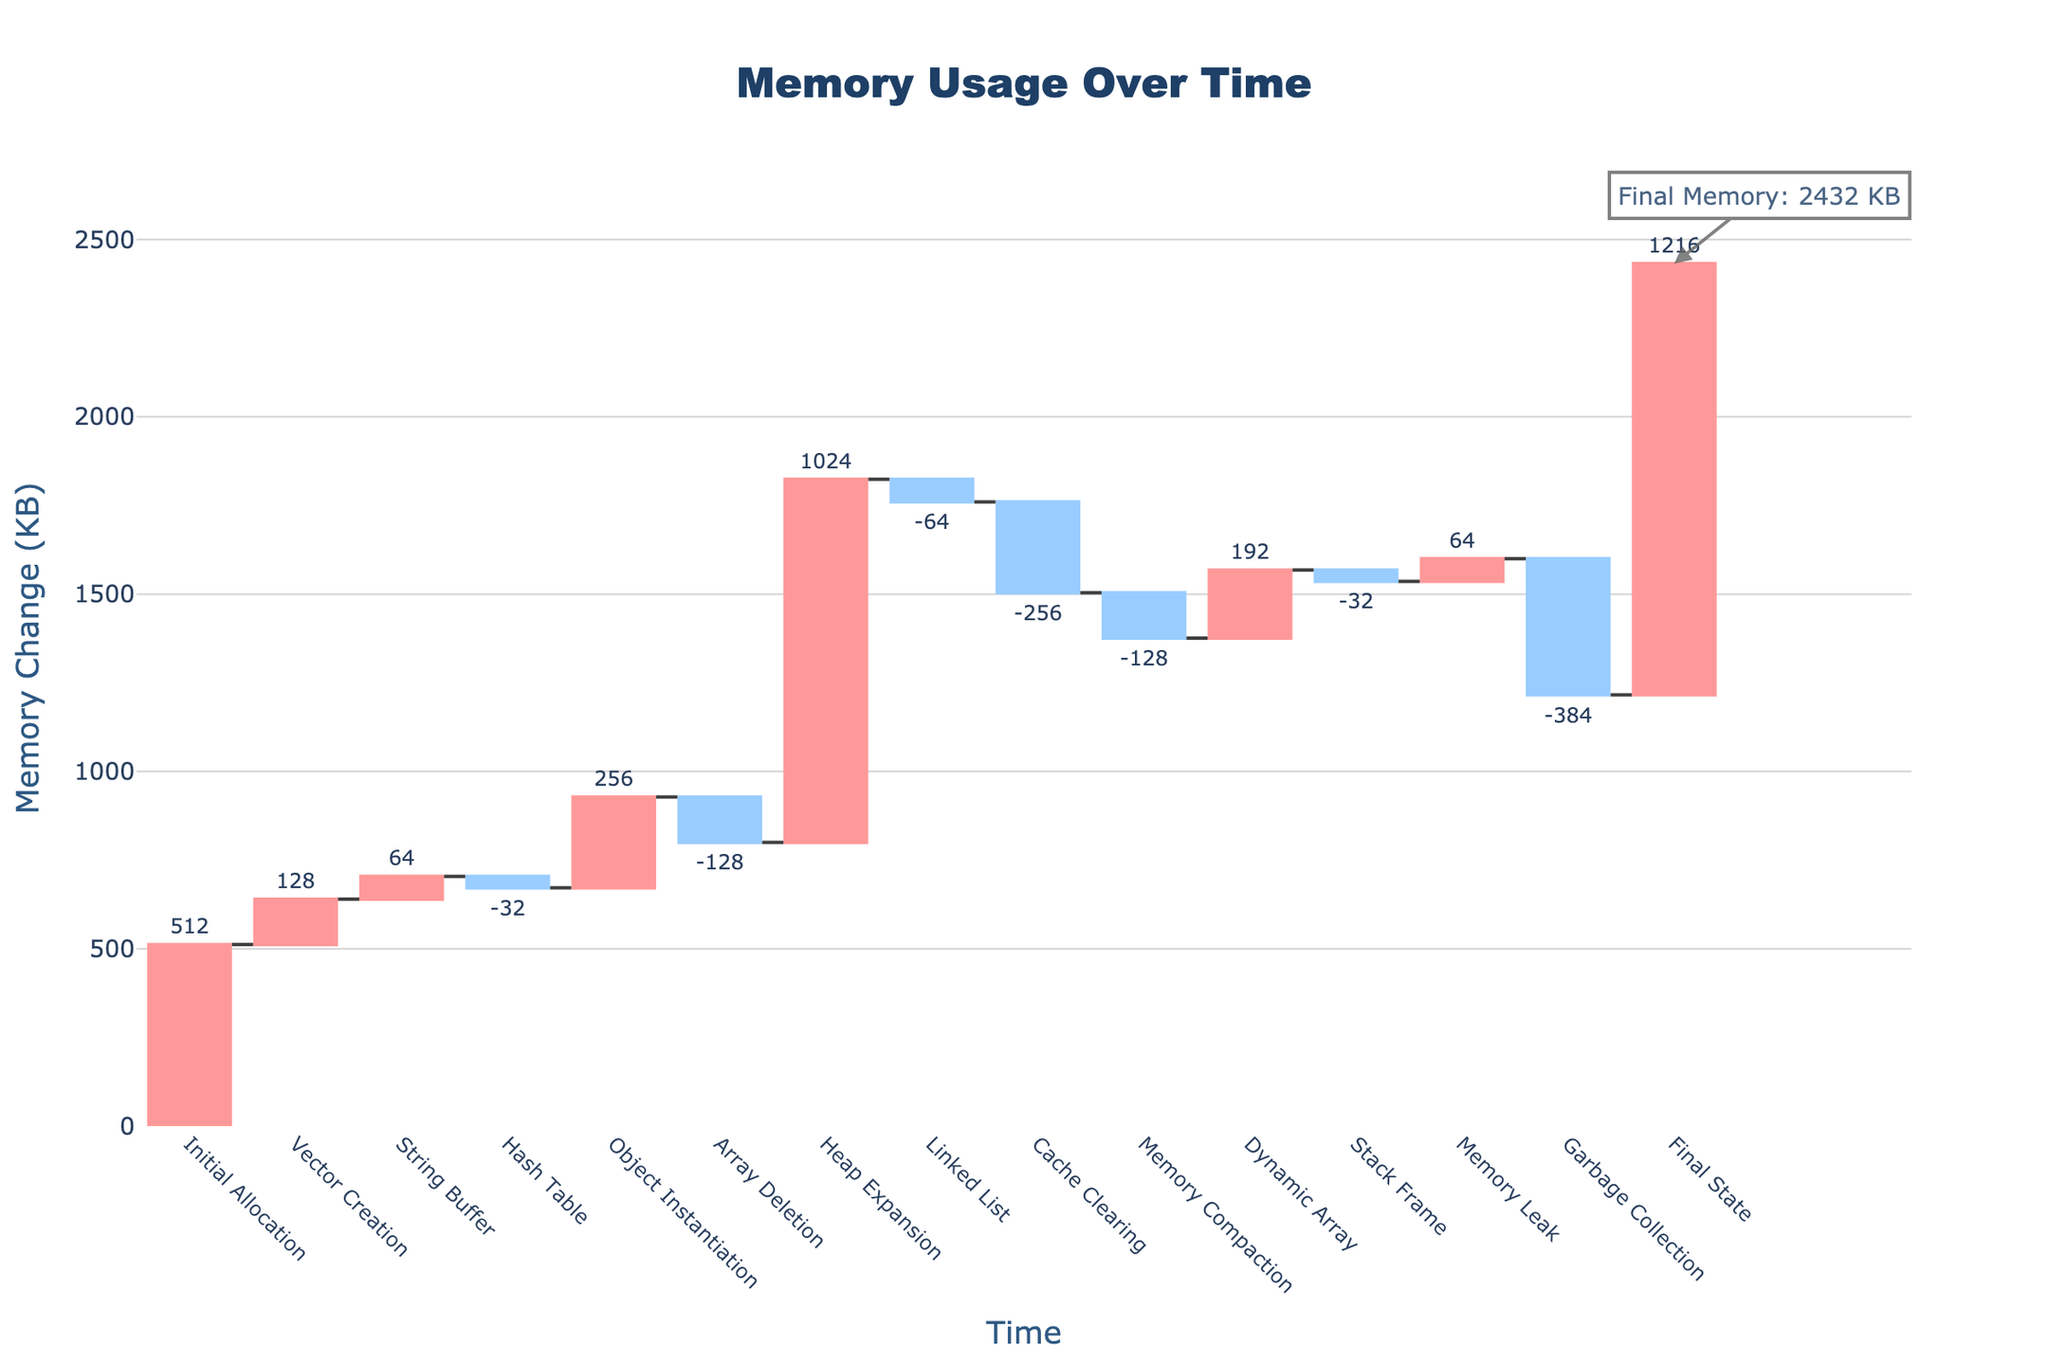What's the title of the chart? The title is displayed at the top of the chart. It is "Memory Usage Over Time".
Answer: Memory Usage Over Time How many operations are displayed in the chart? Each bar in the waterfall chart represents an operation. Counting all the bars will give the number of operations. There are 15 data points.
Answer: 15 Which operation had the largest memory increase? Look for the operation with the tallest bar with a positive memory change color (increasing). The heap expansion has a memory increase of 1024 KB, the largest among all.
Answer: Heap Expansion What is the cumulative memory at the final state? The final cumulative memory is annotated at the rightmost column of the waterfall chart. It indicates 1216 KB.
Answer: 1216 KB What is the memory change during garbage collection? Hovering over the "Garbage Collection" bar provides the memory change information. It shows a decrease of 384 KB.
Answer: -384 KB How much memory was allocated during the vector creation and object instantiation combined? Sum the memory changes for "Vector Creation" and "Object Instantiation". 128 KB (Vector Creation) + 256 KB (Object Instantiation) = 384 KB.
Answer: 384 KB Which operation resulted in the most significant memory decrease? Look for the operation with the tallest bar with a negative memory change color (decreasing). Garbage Collection has a memory decrease of 384 KB, the largest among decreases.
Answer: Garbage Collection Compare the memory change between string buffer and linked list operations. Which one has a larger absolute change? Find the memory changes for "String Buffer" (64 KB increase) and "Linked List" (64 KB decrease). Both have the same absolute change of 64 KB, but in opposite directions.
Answer: They have the same absolute change What was the memory change between time 55 and 65? Identify the memory changes at times 55 (Stack Frame) and 65 (Garbage Collection). Stack Frame = -32 KB, Garbage Collection = -384 KB. Total change = -32 + (-384) = -416 KB.
Answer: -416 KB 